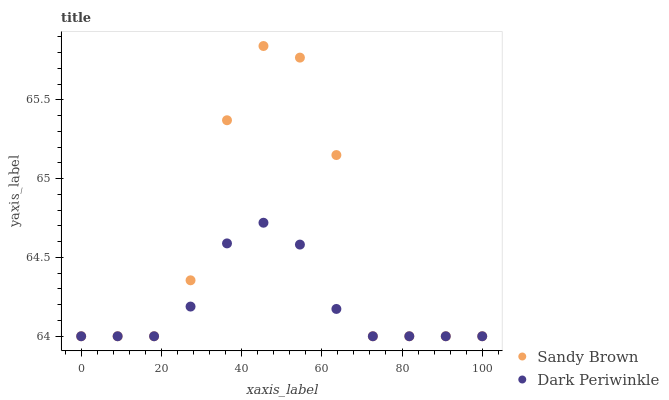Does Dark Periwinkle have the minimum area under the curve?
Answer yes or no. Yes. Does Sandy Brown have the maximum area under the curve?
Answer yes or no. Yes. Does Dark Periwinkle have the maximum area under the curve?
Answer yes or no. No. Is Dark Periwinkle the smoothest?
Answer yes or no. Yes. Is Sandy Brown the roughest?
Answer yes or no. Yes. Is Dark Periwinkle the roughest?
Answer yes or no. No. Does Sandy Brown have the lowest value?
Answer yes or no. Yes. Does Sandy Brown have the highest value?
Answer yes or no. Yes. Does Dark Periwinkle have the highest value?
Answer yes or no. No. Does Dark Periwinkle intersect Sandy Brown?
Answer yes or no. Yes. Is Dark Periwinkle less than Sandy Brown?
Answer yes or no. No. Is Dark Periwinkle greater than Sandy Brown?
Answer yes or no. No. 